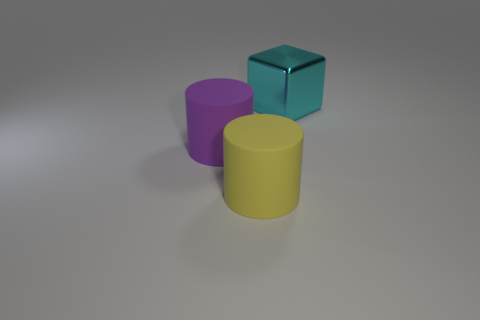How big is the thing that is both behind the big yellow rubber object and in front of the cyan metallic object?
Provide a succinct answer. Large. There is another thing that is the same shape as the large purple thing; what material is it?
Your answer should be compact. Rubber. There is a thing that is to the left of the yellow rubber cylinder; is its size the same as the big yellow rubber cylinder?
Give a very brief answer. Yes. What is the color of the object that is both behind the big yellow rubber cylinder and in front of the metallic block?
Your answer should be very brief. Purple. There is a rubber thing that is in front of the purple rubber thing; what number of large purple cylinders are on the left side of it?
Ensure brevity in your answer.  1. Do the cyan thing and the big purple matte object have the same shape?
Your answer should be compact. No. Are there any other things that have the same color as the large cube?
Provide a short and direct response. No. Is the shape of the cyan metal thing the same as the big rubber object that is left of the yellow matte cylinder?
Your answer should be very brief. No. There is a object that is to the left of the rubber object that is to the right of the purple rubber thing to the left of the yellow matte thing; what color is it?
Offer a very short reply. Purple. Is there anything else that is the same material as the large cyan object?
Give a very brief answer. No. 